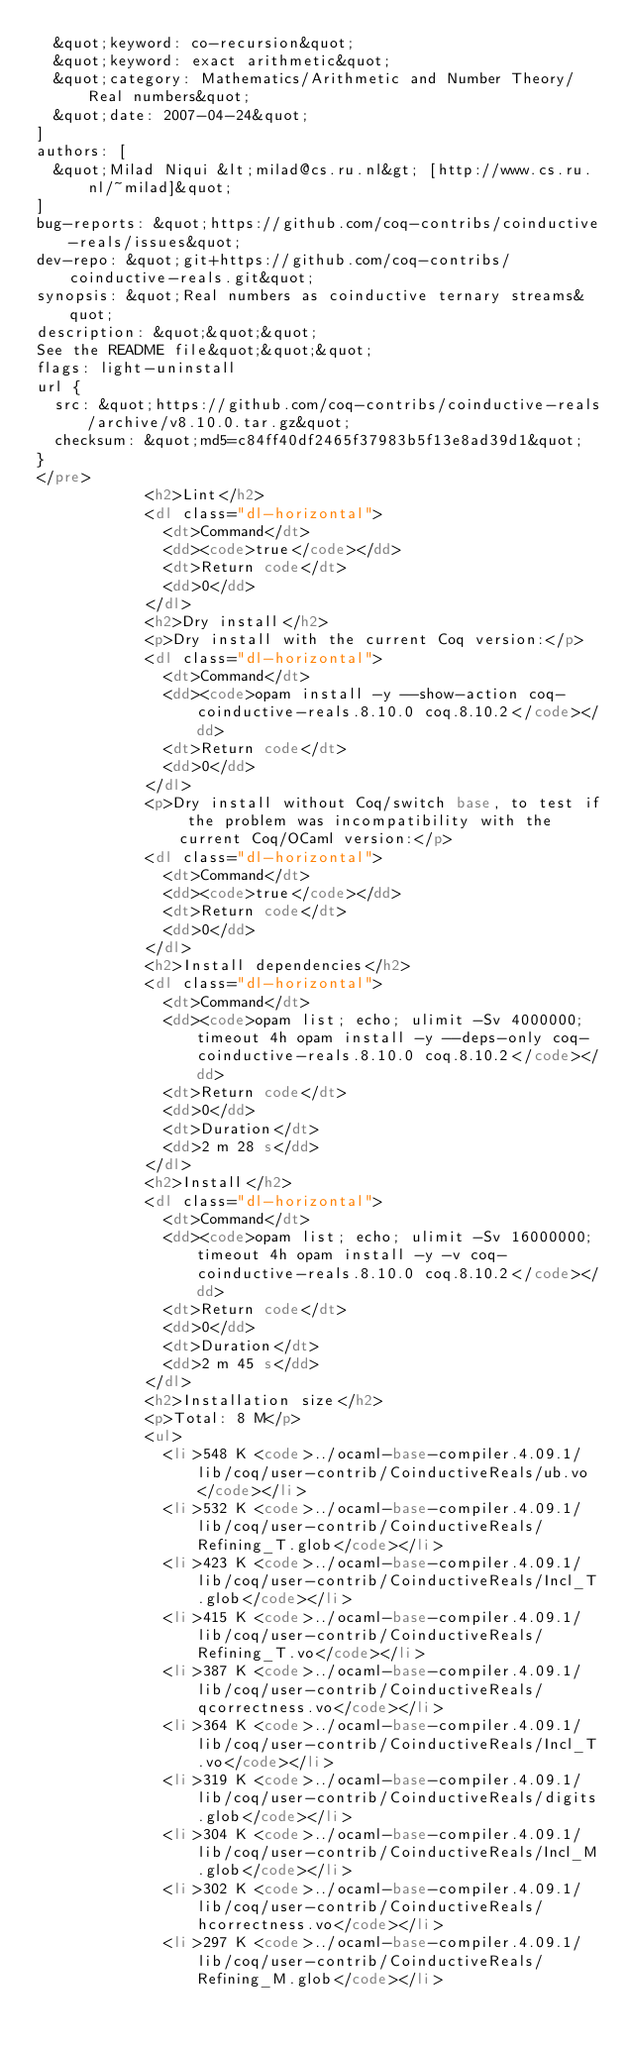Convert code to text. <code><loc_0><loc_0><loc_500><loc_500><_HTML_>  &quot;keyword: co-recursion&quot;
  &quot;keyword: exact arithmetic&quot;
  &quot;category: Mathematics/Arithmetic and Number Theory/Real numbers&quot;
  &quot;date: 2007-04-24&quot;
]
authors: [
  &quot;Milad Niqui &lt;milad@cs.ru.nl&gt; [http://www.cs.ru.nl/~milad]&quot;
]
bug-reports: &quot;https://github.com/coq-contribs/coinductive-reals/issues&quot;
dev-repo: &quot;git+https://github.com/coq-contribs/coinductive-reals.git&quot;
synopsis: &quot;Real numbers as coinductive ternary streams&quot;
description: &quot;&quot;&quot;
See the README file&quot;&quot;&quot;
flags: light-uninstall
url {
  src: &quot;https://github.com/coq-contribs/coinductive-reals/archive/v8.10.0.tar.gz&quot;
  checksum: &quot;md5=c84ff40df2465f37983b5f13e8ad39d1&quot;
}
</pre>
            <h2>Lint</h2>
            <dl class="dl-horizontal">
              <dt>Command</dt>
              <dd><code>true</code></dd>
              <dt>Return code</dt>
              <dd>0</dd>
            </dl>
            <h2>Dry install</h2>
            <p>Dry install with the current Coq version:</p>
            <dl class="dl-horizontal">
              <dt>Command</dt>
              <dd><code>opam install -y --show-action coq-coinductive-reals.8.10.0 coq.8.10.2</code></dd>
              <dt>Return code</dt>
              <dd>0</dd>
            </dl>
            <p>Dry install without Coq/switch base, to test if the problem was incompatibility with the current Coq/OCaml version:</p>
            <dl class="dl-horizontal">
              <dt>Command</dt>
              <dd><code>true</code></dd>
              <dt>Return code</dt>
              <dd>0</dd>
            </dl>
            <h2>Install dependencies</h2>
            <dl class="dl-horizontal">
              <dt>Command</dt>
              <dd><code>opam list; echo; ulimit -Sv 4000000; timeout 4h opam install -y --deps-only coq-coinductive-reals.8.10.0 coq.8.10.2</code></dd>
              <dt>Return code</dt>
              <dd>0</dd>
              <dt>Duration</dt>
              <dd>2 m 28 s</dd>
            </dl>
            <h2>Install</h2>
            <dl class="dl-horizontal">
              <dt>Command</dt>
              <dd><code>opam list; echo; ulimit -Sv 16000000; timeout 4h opam install -y -v coq-coinductive-reals.8.10.0 coq.8.10.2</code></dd>
              <dt>Return code</dt>
              <dd>0</dd>
              <dt>Duration</dt>
              <dd>2 m 45 s</dd>
            </dl>
            <h2>Installation size</h2>
            <p>Total: 8 M</p>
            <ul>
              <li>548 K <code>../ocaml-base-compiler.4.09.1/lib/coq/user-contrib/CoinductiveReals/ub.vo</code></li>
              <li>532 K <code>../ocaml-base-compiler.4.09.1/lib/coq/user-contrib/CoinductiveReals/Refining_T.glob</code></li>
              <li>423 K <code>../ocaml-base-compiler.4.09.1/lib/coq/user-contrib/CoinductiveReals/Incl_T.glob</code></li>
              <li>415 K <code>../ocaml-base-compiler.4.09.1/lib/coq/user-contrib/CoinductiveReals/Refining_T.vo</code></li>
              <li>387 K <code>../ocaml-base-compiler.4.09.1/lib/coq/user-contrib/CoinductiveReals/qcorrectness.vo</code></li>
              <li>364 K <code>../ocaml-base-compiler.4.09.1/lib/coq/user-contrib/CoinductiveReals/Incl_T.vo</code></li>
              <li>319 K <code>../ocaml-base-compiler.4.09.1/lib/coq/user-contrib/CoinductiveReals/digits.glob</code></li>
              <li>304 K <code>../ocaml-base-compiler.4.09.1/lib/coq/user-contrib/CoinductiveReals/Incl_M.glob</code></li>
              <li>302 K <code>../ocaml-base-compiler.4.09.1/lib/coq/user-contrib/CoinductiveReals/hcorrectness.vo</code></li>
              <li>297 K <code>../ocaml-base-compiler.4.09.1/lib/coq/user-contrib/CoinductiveReals/Refining_M.glob</code></li></code> 